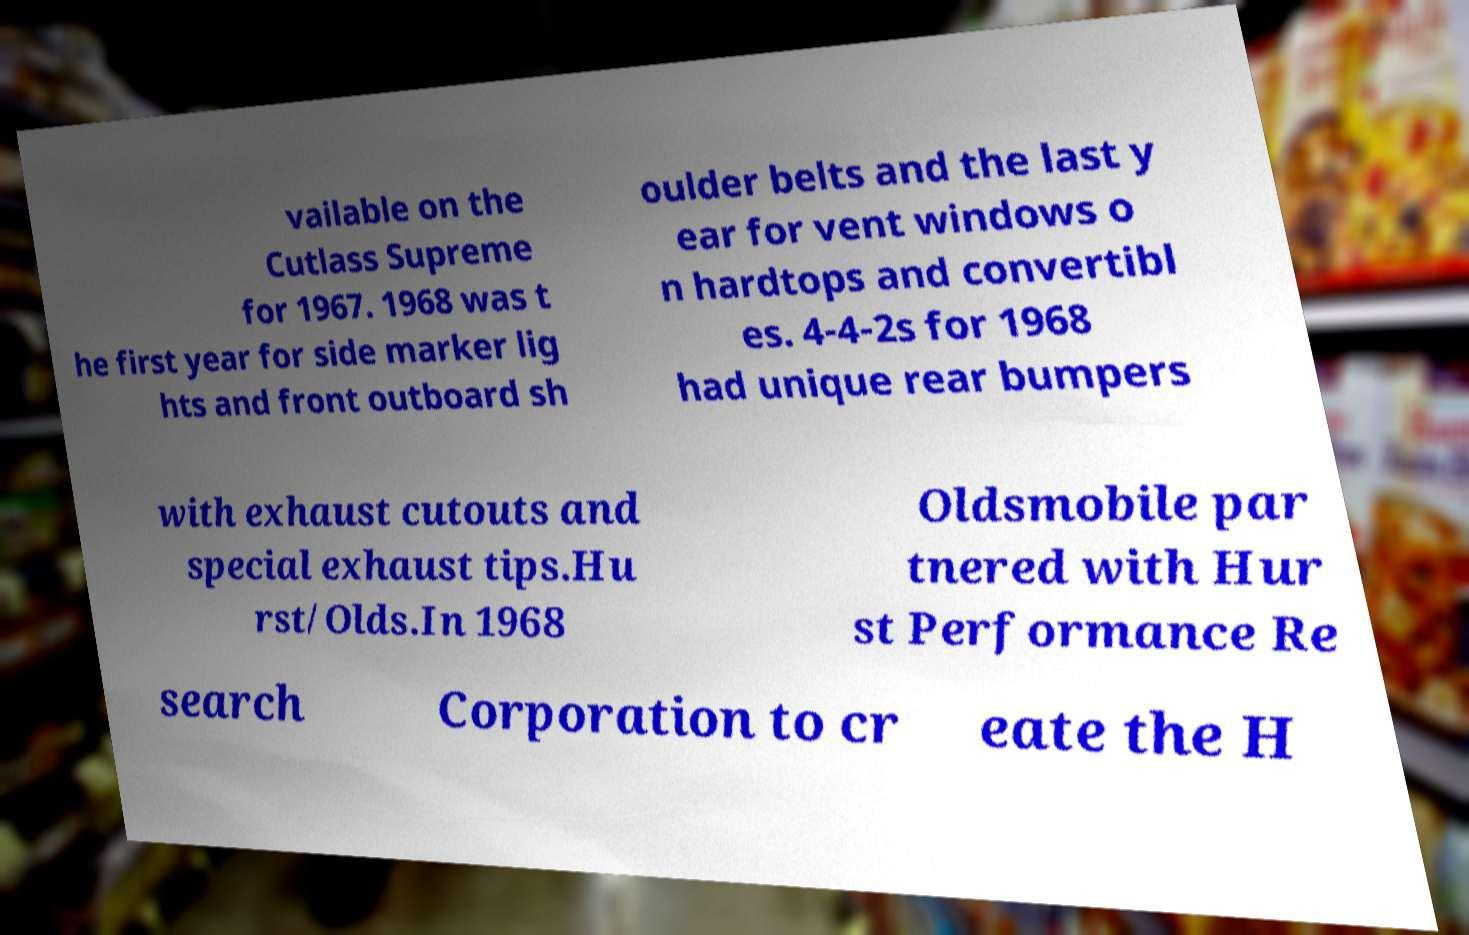I need the written content from this picture converted into text. Can you do that? vailable on the Cutlass Supreme for 1967. 1968 was t he first year for side marker lig hts and front outboard sh oulder belts and the last y ear for vent windows o n hardtops and convertibl es. 4-4-2s for 1968 had unique rear bumpers with exhaust cutouts and special exhaust tips.Hu rst/Olds.In 1968 Oldsmobile par tnered with Hur st Performance Re search Corporation to cr eate the H 